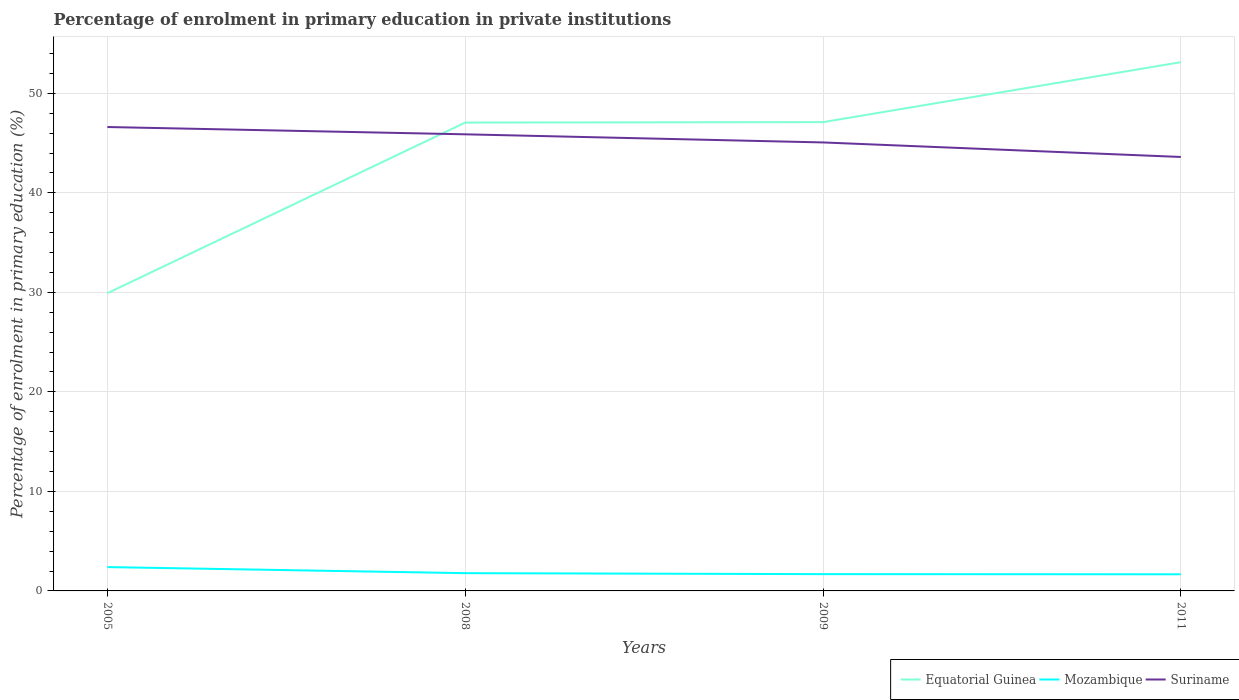Is the number of lines equal to the number of legend labels?
Keep it short and to the point. Yes. Across all years, what is the maximum percentage of enrolment in primary education in Equatorial Guinea?
Your answer should be very brief. 29.91. What is the total percentage of enrolment in primary education in Mozambique in the graph?
Offer a very short reply. 0.11. What is the difference between the highest and the second highest percentage of enrolment in primary education in Mozambique?
Make the answer very short. 0.72. What is the difference between the highest and the lowest percentage of enrolment in primary education in Mozambique?
Ensure brevity in your answer.  1. What is the difference between two consecutive major ticks on the Y-axis?
Give a very brief answer. 10. Does the graph contain any zero values?
Keep it short and to the point. No. Does the graph contain grids?
Make the answer very short. Yes. Where does the legend appear in the graph?
Your answer should be very brief. Bottom right. What is the title of the graph?
Keep it short and to the point. Percentage of enrolment in primary education in private institutions. What is the label or title of the X-axis?
Your answer should be compact. Years. What is the label or title of the Y-axis?
Provide a succinct answer. Percentage of enrolment in primary education (%). What is the Percentage of enrolment in primary education (%) of Equatorial Guinea in 2005?
Your response must be concise. 29.91. What is the Percentage of enrolment in primary education (%) in Mozambique in 2005?
Keep it short and to the point. 2.4. What is the Percentage of enrolment in primary education (%) in Suriname in 2005?
Your answer should be very brief. 46.61. What is the Percentage of enrolment in primary education (%) of Equatorial Guinea in 2008?
Your response must be concise. 47.06. What is the Percentage of enrolment in primary education (%) of Mozambique in 2008?
Your answer should be compact. 1.79. What is the Percentage of enrolment in primary education (%) in Suriname in 2008?
Make the answer very short. 45.88. What is the Percentage of enrolment in primary education (%) in Equatorial Guinea in 2009?
Provide a succinct answer. 47.11. What is the Percentage of enrolment in primary education (%) in Mozambique in 2009?
Ensure brevity in your answer.  1.69. What is the Percentage of enrolment in primary education (%) in Suriname in 2009?
Offer a terse response. 45.06. What is the Percentage of enrolment in primary education (%) of Equatorial Guinea in 2011?
Provide a short and direct response. 53.13. What is the Percentage of enrolment in primary education (%) in Mozambique in 2011?
Keep it short and to the point. 1.67. What is the Percentage of enrolment in primary education (%) in Suriname in 2011?
Provide a short and direct response. 43.6. Across all years, what is the maximum Percentage of enrolment in primary education (%) in Equatorial Guinea?
Make the answer very short. 53.13. Across all years, what is the maximum Percentage of enrolment in primary education (%) in Mozambique?
Offer a very short reply. 2.4. Across all years, what is the maximum Percentage of enrolment in primary education (%) of Suriname?
Offer a terse response. 46.61. Across all years, what is the minimum Percentage of enrolment in primary education (%) of Equatorial Guinea?
Your answer should be compact. 29.91. Across all years, what is the minimum Percentage of enrolment in primary education (%) in Mozambique?
Offer a very short reply. 1.67. Across all years, what is the minimum Percentage of enrolment in primary education (%) of Suriname?
Ensure brevity in your answer.  43.6. What is the total Percentage of enrolment in primary education (%) in Equatorial Guinea in the graph?
Provide a succinct answer. 177.21. What is the total Percentage of enrolment in primary education (%) in Mozambique in the graph?
Make the answer very short. 7.54. What is the total Percentage of enrolment in primary education (%) of Suriname in the graph?
Offer a terse response. 181.16. What is the difference between the Percentage of enrolment in primary education (%) of Equatorial Guinea in 2005 and that in 2008?
Your response must be concise. -17.15. What is the difference between the Percentage of enrolment in primary education (%) in Mozambique in 2005 and that in 2008?
Your answer should be compact. 0.61. What is the difference between the Percentage of enrolment in primary education (%) of Suriname in 2005 and that in 2008?
Make the answer very short. 0.73. What is the difference between the Percentage of enrolment in primary education (%) in Equatorial Guinea in 2005 and that in 2009?
Your answer should be very brief. -17.19. What is the difference between the Percentage of enrolment in primary education (%) in Mozambique in 2005 and that in 2009?
Provide a succinct answer. 0.71. What is the difference between the Percentage of enrolment in primary education (%) of Suriname in 2005 and that in 2009?
Offer a very short reply. 1.55. What is the difference between the Percentage of enrolment in primary education (%) in Equatorial Guinea in 2005 and that in 2011?
Your answer should be compact. -23.21. What is the difference between the Percentage of enrolment in primary education (%) of Mozambique in 2005 and that in 2011?
Your answer should be very brief. 0.72. What is the difference between the Percentage of enrolment in primary education (%) in Suriname in 2005 and that in 2011?
Make the answer very short. 3.01. What is the difference between the Percentage of enrolment in primary education (%) of Equatorial Guinea in 2008 and that in 2009?
Provide a succinct answer. -0.04. What is the difference between the Percentage of enrolment in primary education (%) of Mozambique in 2008 and that in 2009?
Offer a very short reply. 0.1. What is the difference between the Percentage of enrolment in primary education (%) of Suriname in 2008 and that in 2009?
Your response must be concise. 0.82. What is the difference between the Percentage of enrolment in primary education (%) of Equatorial Guinea in 2008 and that in 2011?
Offer a very short reply. -6.07. What is the difference between the Percentage of enrolment in primary education (%) of Mozambique in 2008 and that in 2011?
Make the answer very short. 0.11. What is the difference between the Percentage of enrolment in primary education (%) of Suriname in 2008 and that in 2011?
Give a very brief answer. 2.28. What is the difference between the Percentage of enrolment in primary education (%) in Equatorial Guinea in 2009 and that in 2011?
Give a very brief answer. -6.02. What is the difference between the Percentage of enrolment in primary education (%) of Mozambique in 2009 and that in 2011?
Ensure brevity in your answer.  0.02. What is the difference between the Percentage of enrolment in primary education (%) of Suriname in 2009 and that in 2011?
Make the answer very short. 1.46. What is the difference between the Percentage of enrolment in primary education (%) in Equatorial Guinea in 2005 and the Percentage of enrolment in primary education (%) in Mozambique in 2008?
Give a very brief answer. 28.13. What is the difference between the Percentage of enrolment in primary education (%) of Equatorial Guinea in 2005 and the Percentage of enrolment in primary education (%) of Suriname in 2008?
Your answer should be very brief. -15.97. What is the difference between the Percentage of enrolment in primary education (%) of Mozambique in 2005 and the Percentage of enrolment in primary education (%) of Suriname in 2008?
Your answer should be compact. -43.48. What is the difference between the Percentage of enrolment in primary education (%) of Equatorial Guinea in 2005 and the Percentage of enrolment in primary education (%) of Mozambique in 2009?
Your response must be concise. 28.23. What is the difference between the Percentage of enrolment in primary education (%) in Equatorial Guinea in 2005 and the Percentage of enrolment in primary education (%) in Suriname in 2009?
Give a very brief answer. -15.15. What is the difference between the Percentage of enrolment in primary education (%) in Mozambique in 2005 and the Percentage of enrolment in primary education (%) in Suriname in 2009?
Your answer should be very brief. -42.67. What is the difference between the Percentage of enrolment in primary education (%) in Equatorial Guinea in 2005 and the Percentage of enrolment in primary education (%) in Mozambique in 2011?
Give a very brief answer. 28.24. What is the difference between the Percentage of enrolment in primary education (%) of Equatorial Guinea in 2005 and the Percentage of enrolment in primary education (%) of Suriname in 2011?
Keep it short and to the point. -13.69. What is the difference between the Percentage of enrolment in primary education (%) of Mozambique in 2005 and the Percentage of enrolment in primary education (%) of Suriname in 2011?
Your answer should be compact. -41.21. What is the difference between the Percentage of enrolment in primary education (%) in Equatorial Guinea in 2008 and the Percentage of enrolment in primary education (%) in Mozambique in 2009?
Your answer should be compact. 45.38. What is the difference between the Percentage of enrolment in primary education (%) in Equatorial Guinea in 2008 and the Percentage of enrolment in primary education (%) in Suriname in 2009?
Your answer should be very brief. 2. What is the difference between the Percentage of enrolment in primary education (%) of Mozambique in 2008 and the Percentage of enrolment in primary education (%) of Suriname in 2009?
Your response must be concise. -43.28. What is the difference between the Percentage of enrolment in primary education (%) of Equatorial Guinea in 2008 and the Percentage of enrolment in primary education (%) of Mozambique in 2011?
Your answer should be compact. 45.39. What is the difference between the Percentage of enrolment in primary education (%) in Equatorial Guinea in 2008 and the Percentage of enrolment in primary education (%) in Suriname in 2011?
Your response must be concise. 3.46. What is the difference between the Percentage of enrolment in primary education (%) of Mozambique in 2008 and the Percentage of enrolment in primary education (%) of Suriname in 2011?
Ensure brevity in your answer.  -41.82. What is the difference between the Percentage of enrolment in primary education (%) of Equatorial Guinea in 2009 and the Percentage of enrolment in primary education (%) of Mozambique in 2011?
Ensure brevity in your answer.  45.43. What is the difference between the Percentage of enrolment in primary education (%) of Equatorial Guinea in 2009 and the Percentage of enrolment in primary education (%) of Suriname in 2011?
Offer a very short reply. 3.5. What is the difference between the Percentage of enrolment in primary education (%) of Mozambique in 2009 and the Percentage of enrolment in primary education (%) of Suriname in 2011?
Your answer should be compact. -41.92. What is the average Percentage of enrolment in primary education (%) of Equatorial Guinea per year?
Your answer should be compact. 44.3. What is the average Percentage of enrolment in primary education (%) in Mozambique per year?
Your answer should be compact. 1.88. What is the average Percentage of enrolment in primary education (%) in Suriname per year?
Make the answer very short. 45.29. In the year 2005, what is the difference between the Percentage of enrolment in primary education (%) of Equatorial Guinea and Percentage of enrolment in primary education (%) of Mozambique?
Make the answer very short. 27.52. In the year 2005, what is the difference between the Percentage of enrolment in primary education (%) of Equatorial Guinea and Percentage of enrolment in primary education (%) of Suriname?
Your answer should be very brief. -16.7. In the year 2005, what is the difference between the Percentage of enrolment in primary education (%) of Mozambique and Percentage of enrolment in primary education (%) of Suriname?
Your answer should be very brief. -44.22. In the year 2008, what is the difference between the Percentage of enrolment in primary education (%) of Equatorial Guinea and Percentage of enrolment in primary education (%) of Mozambique?
Your response must be concise. 45.28. In the year 2008, what is the difference between the Percentage of enrolment in primary education (%) of Equatorial Guinea and Percentage of enrolment in primary education (%) of Suriname?
Your response must be concise. 1.18. In the year 2008, what is the difference between the Percentage of enrolment in primary education (%) in Mozambique and Percentage of enrolment in primary education (%) in Suriname?
Offer a terse response. -44.1. In the year 2009, what is the difference between the Percentage of enrolment in primary education (%) of Equatorial Guinea and Percentage of enrolment in primary education (%) of Mozambique?
Offer a very short reply. 45.42. In the year 2009, what is the difference between the Percentage of enrolment in primary education (%) in Equatorial Guinea and Percentage of enrolment in primary education (%) in Suriname?
Offer a very short reply. 2.04. In the year 2009, what is the difference between the Percentage of enrolment in primary education (%) in Mozambique and Percentage of enrolment in primary education (%) in Suriname?
Your answer should be very brief. -43.38. In the year 2011, what is the difference between the Percentage of enrolment in primary education (%) in Equatorial Guinea and Percentage of enrolment in primary education (%) in Mozambique?
Your answer should be compact. 51.46. In the year 2011, what is the difference between the Percentage of enrolment in primary education (%) in Equatorial Guinea and Percentage of enrolment in primary education (%) in Suriname?
Offer a very short reply. 9.53. In the year 2011, what is the difference between the Percentage of enrolment in primary education (%) in Mozambique and Percentage of enrolment in primary education (%) in Suriname?
Your answer should be compact. -41.93. What is the ratio of the Percentage of enrolment in primary education (%) of Equatorial Guinea in 2005 to that in 2008?
Your answer should be compact. 0.64. What is the ratio of the Percentage of enrolment in primary education (%) in Mozambique in 2005 to that in 2008?
Your answer should be very brief. 1.34. What is the ratio of the Percentage of enrolment in primary education (%) of Equatorial Guinea in 2005 to that in 2009?
Provide a short and direct response. 0.64. What is the ratio of the Percentage of enrolment in primary education (%) of Mozambique in 2005 to that in 2009?
Make the answer very short. 1.42. What is the ratio of the Percentage of enrolment in primary education (%) in Suriname in 2005 to that in 2009?
Provide a succinct answer. 1.03. What is the ratio of the Percentage of enrolment in primary education (%) of Equatorial Guinea in 2005 to that in 2011?
Give a very brief answer. 0.56. What is the ratio of the Percentage of enrolment in primary education (%) of Mozambique in 2005 to that in 2011?
Keep it short and to the point. 1.43. What is the ratio of the Percentage of enrolment in primary education (%) of Suriname in 2005 to that in 2011?
Keep it short and to the point. 1.07. What is the ratio of the Percentage of enrolment in primary education (%) of Equatorial Guinea in 2008 to that in 2009?
Your answer should be very brief. 1. What is the ratio of the Percentage of enrolment in primary education (%) of Mozambique in 2008 to that in 2009?
Offer a very short reply. 1.06. What is the ratio of the Percentage of enrolment in primary education (%) in Suriname in 2008 to that in 2009?
Provide a succinct answer. 1.02. What is the ratio of the Percentage of enrolment in primary education (%) in Equatorial Guinea in 2008 to that in 2011?
Offer a terse response. 0.89. What is the ratio of the Percentage of enrolment in primary education (%) of Mozambique in 2008 to that in 2011?
Keep it short and to the point. 1.07. What is the ratio of the Percentage of enrolment in primary education (%) in Suriname in 2008 to that in 2011?
Provide a short and direct response. 1.05. What is the ratio of the Percentage of enrolment in primary education (%) in Equatorial Guinea in 2009 to that in 2011?
Provide a succinct answer. 0.89. What is the ratio of the Percentage of enrolment in primary education (%) in Mozambique in 2009 to that in 2011?
Give a very brief answer. 1.01. What is the ratio of the Percentage of enrolment in primary education (%) in Suriname in 2009 to that in 2011?
Keep it short and to the point. 1.03. What is the difference between the highest and the second highest Percentage of enrolment in primary education (%) of Equatorial Guinea?
Offer a terse response. 6.02. What is the difference between the highest and the second highest Percentage of enrolment in primary education (%) in Mozambique?
Your answer should be compact. 0.61. What is the difference between the highest and the second highest Percentage of enrolment in primary education (%) of Suriname?
Your answer should be very brief. 0.73. What is the difference between the highest and the lowest Percentage of enrolment in primary education (%) in Equatorial Guinea?
Provide a short and direct response. 23.21. What is the difference between the highest and the lowest Percentage of enrolment in primary education (%) in Mozambique?
Your answer should be compact. 0.72. What is the difference between the highest and the lowest Percentage of enrolment in primary education (%) of Suriname?
Offer a very short reply. 3.01. 